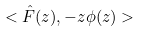Convert formula to latex. <formula><loc_0><loc_0><loc_500><loc_500>< \hat { F } ( z ) , - z \phi ( z ) ></formula> 